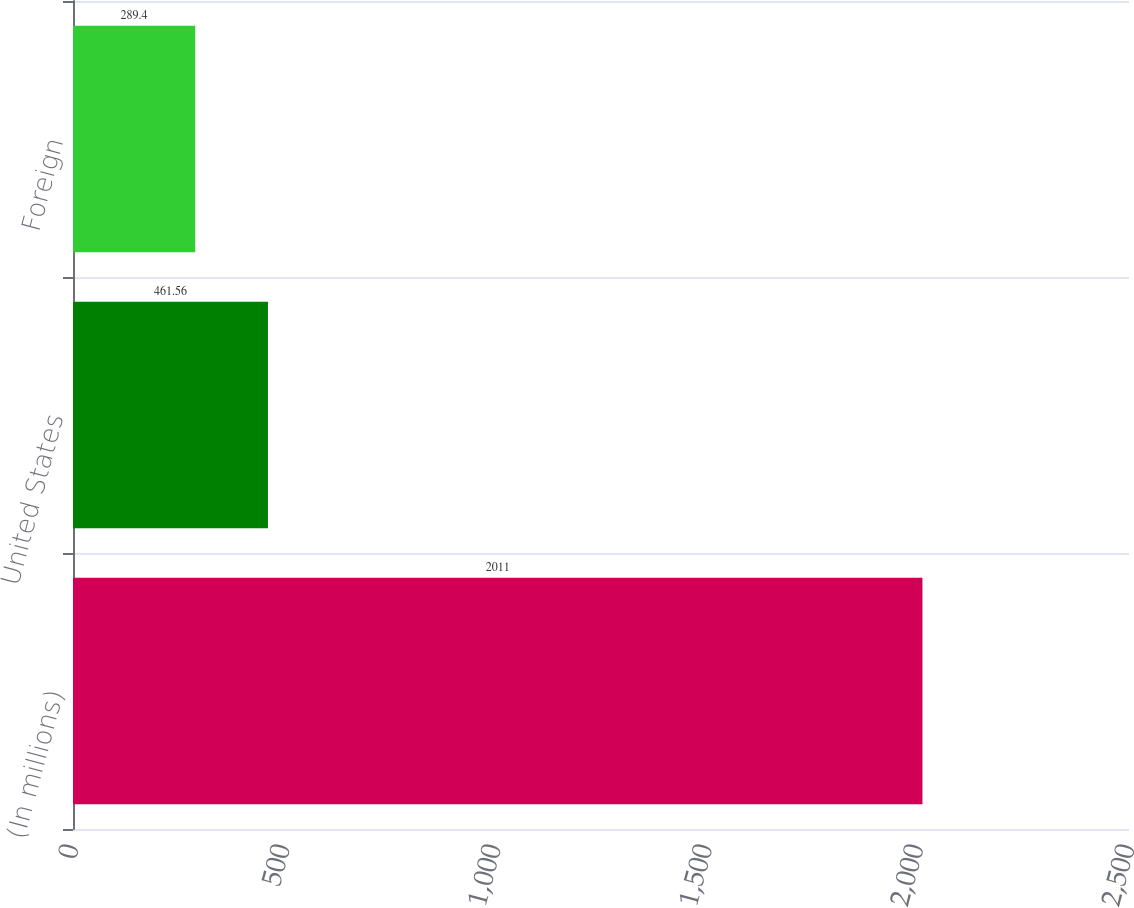<chart> <loc_0><loc_0><loc_500><loc_500><bar_chart><fcel>(In millions)<fcel>United States<fcel>Foreign<nl><fcel>2011<fcel>461.56<fcel>289.4<nl></chart> 